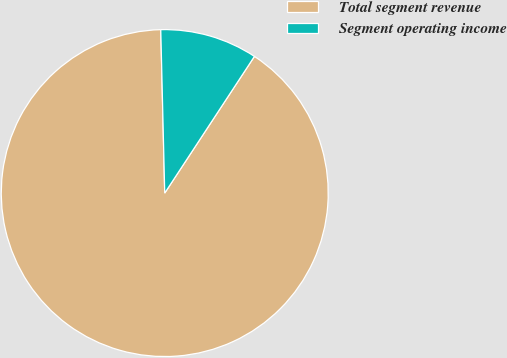Convert chart. <chart><loc_0><loc_0><loc_500><loc_500><pie_chart><fcel>Total segment revenue<fcel>Segment operating income<nl><fcel>90.37%<fcel>9.63%<nl></chart> 